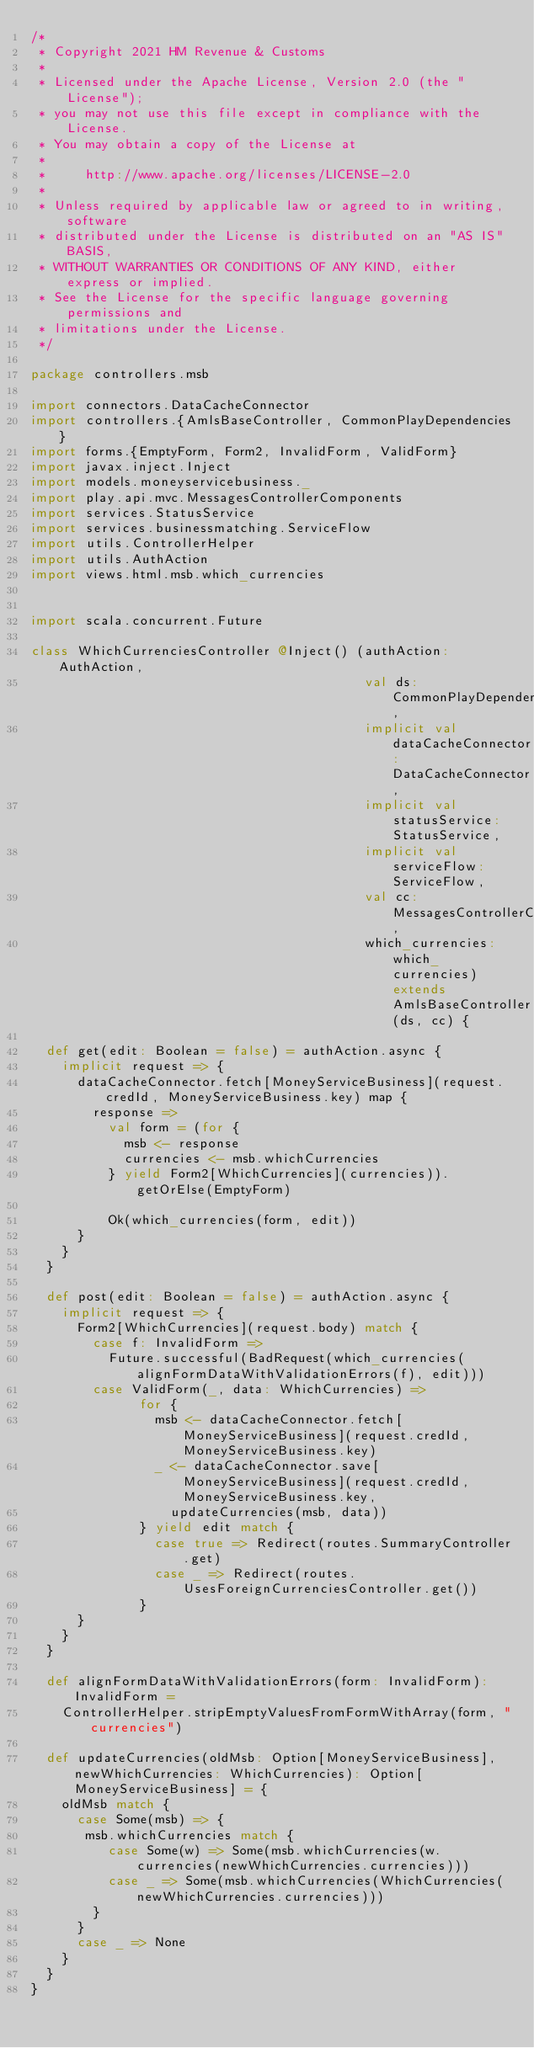Convert code to text. <code><loc_0><loc_0><loc_500><loc_500><_Scala_>/*
 * Copyright 2021 HM Revenue & Customs
 *
 * Licensed under the Apache License, Version 2.0 (the "License");
 * you may not use this file except in compliance with the License.
 * You may obtain a copy of the License at
 *
 *     http://www.apache.org/licenses/LICENSE-2.0
 *
 * Unless required by applicable law or agreed to in writing, software
 * distributed under the License is distributed on an "AS IS" BASIS,
 * WITHOUT WARRANTIES OR CONDITIONS OF ANY KIND, either express or implied.
 * See the License for the specific language governing permissions and
 * limitations under the License.
 */

package controllers.msb

import connectors.DataCacheConnector
import controllers.{AmlsBaseController, CommonPlayDependencies}
import forms.{EmptyForm, Form2, InvalidForm, ValidForm}
import javax.inject.Inject
import models.moneyservicebusiness._
import play.api.mvc.MessagesControllerComponents
import services.StatusService
import services.businessmatching.ServiceFlow
import utils.ControllerHelper
import utils.AuthAction
import views.html.msb.which_currencies


import scala.concurrent.Future

class WhichCurrenciesController @Inject() (authAction: AuthAction,
                                           val ds: CommonPlayDependencies,
                                           implicit val dataCacheConnector: DataCacheConnector,
                                           implicit val statusService: StatusService,
                                           implicit val serviceFlow: ServiceFlow,
                                           val cc: MessagesControllerComponents,
                                           which_currencies: which_currencies) extends AmlsBaseController(ds, cc) {

  def get(edit: Boolean = false) = authAction.async {
    implicit request => {
      dataCacheConnector.fetch[MoneyServiceBusiness](request.credId, MoneyServiceBusiness.key) map {
        response =>
          val form = (for {
            msb <- response
            currencies <- msb.whichCurrencies
          } yield Form2[WhichCurrencies](currencies)).getOrElse(EmptyForm)

          Ok(which_currencies(form, edit))
      }
    }
  }

  def post(edit: Boolean = false) = authAction.async {
    implicit request => {
      Form2[WhichCurrencies](request.body) match {
        case f: InvalidForm =>
          Future.successful(BadRequest(which_currencies(alignFormDataWithValidationErrors(f), edit)))
        case ValidForm(_, data: WhichCurrencies) =>
              for {
                msb <- dataCacheConnector.fetch[MoneyServiceBusiness](request.credId, MoneyServiceBusiness.key)
                _ <- dataCacheConnector.save[MoneyServiceBusiness](request.credId, MoneyServiceBusiness.key,
                  updateCurrencies(msb, data))
              } yield edit match {
                case true => Redirect(routes.SummaryController.get)
                case _ => Redirect(routes.UsesForeignCurrenciesController.get())
              }
      }
    }
  }

  def alignFormDataWithValidationErrors(form: InvalidForm): InvalidForm =
    ControllerHelper.stripEmptyValuesFromFormWithArray(form, "currencies")

  def updateCurrencies(oldMsb: Option[MoneyServiceBusiness], newWhichCurrencies: WhichCurrencies): Option[MoneyServiceBusiness] = {
    oldMsb match {
      case Some(msb) => {
       msb.whichCurrencies match {
          case Some(w) => Some(msb.whichCurrencies(w.currencies(newWhichCurrencies.currencies)))
          case _ => Some(msb.whichCurrencies(WhichCurrencies(newWhichCurrencies.currencies)))
        }
      }
      case _ => None
    }
  }
}
</code> 